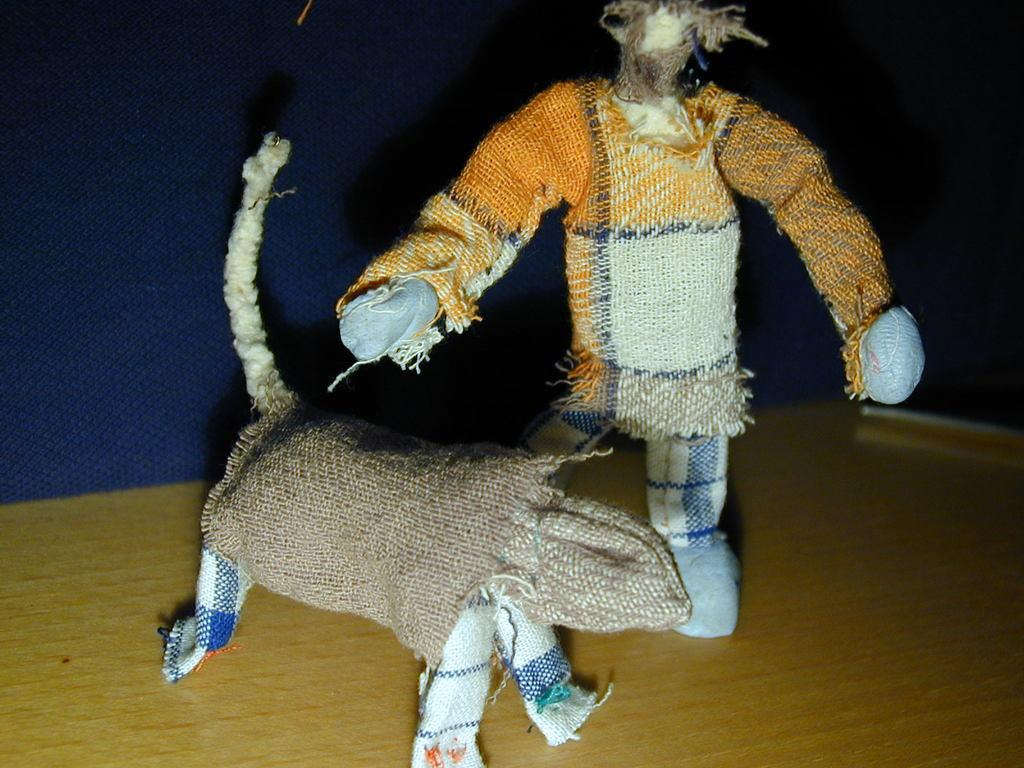What objects are present in the image? There are two toys in the image. What are the toys made of? The toys are made of cloth. Where are the toys located in the image? The toys are on the floor. What type of end can be seen on the toys in the image? There is no specific end mentioned or visible on the toys in the image; they are made of cloth and are on the floor. 